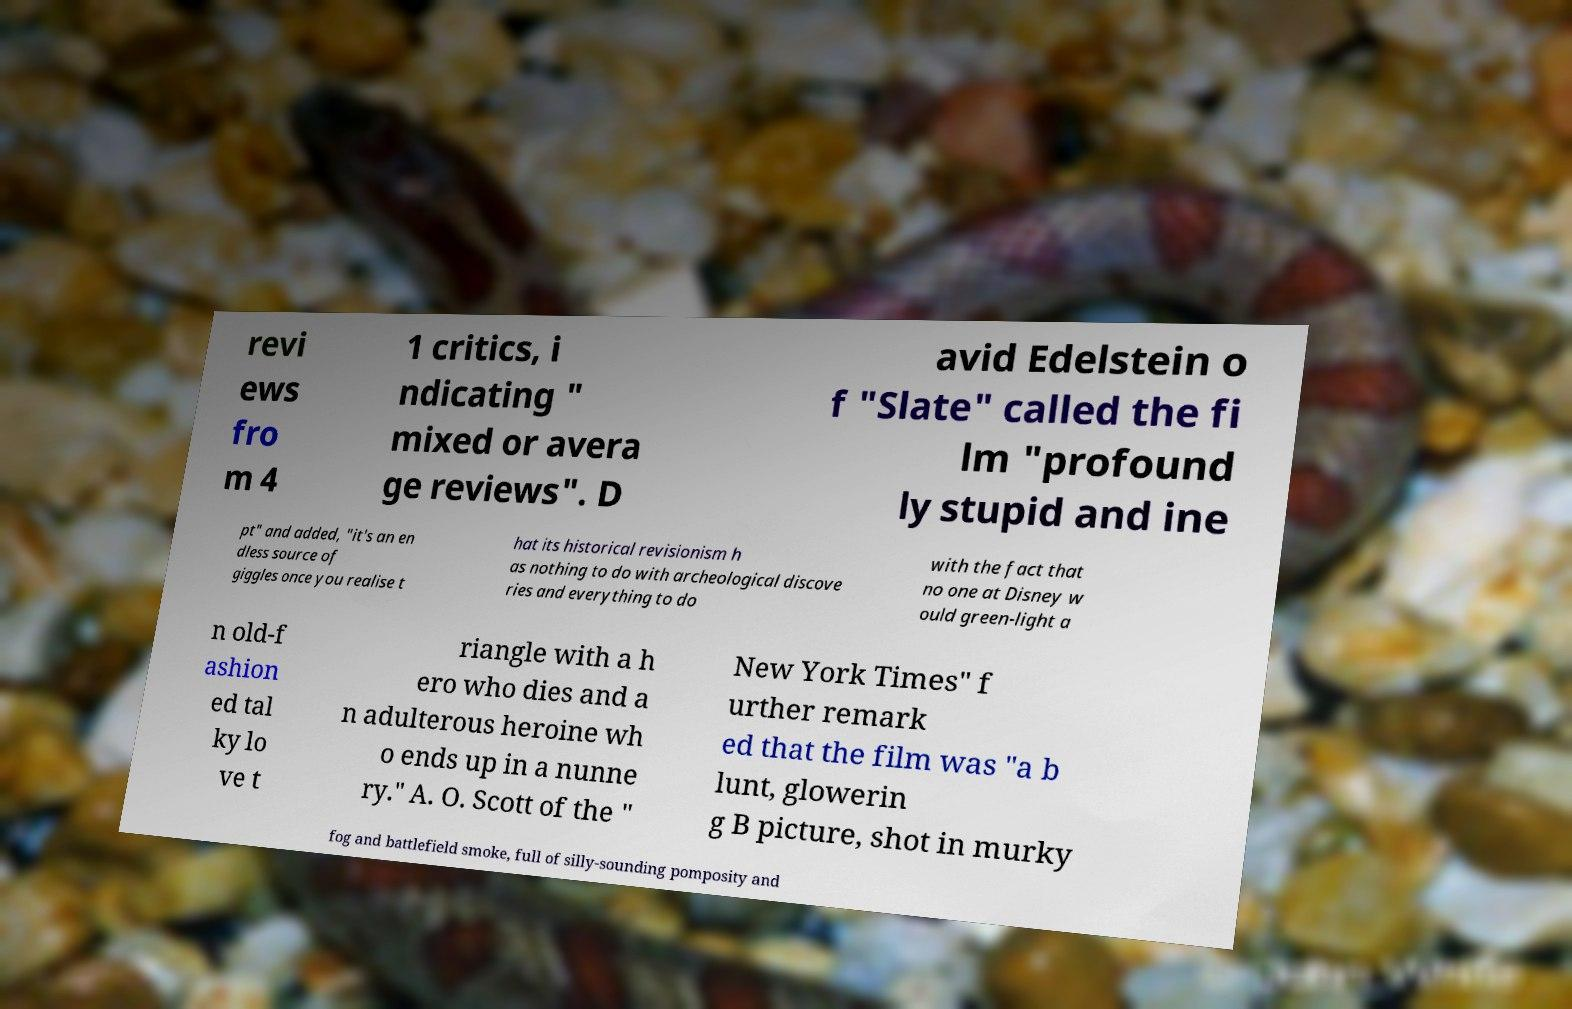For documentation purposes, I need the text within this image transcribed. Could you provide that? revi ews fro m 4 1 critics, i ndicating " mixed or avera ge reviews". D avid Edelstein o f "Slate" called the fi lm "profound ly stupid and ine pt" and added, "it's an en dless source of giggles once you realise t hat its historical revisionism h as nothing to do with archeological discove ries and everything to do with the fact that no one at Disney w ould green-light a n old-f ashion ed tal ky lo ve t riangle with a h ero who dies and a n adulterous heroine wh o ends up in a nunne ry." A. O. Scott of the " New York Times" f urther remark ed that the film was "a b lunt, glowerin g B picture, shot in murky fog and battlefield smoke, full of silly-sounding pomposity and 